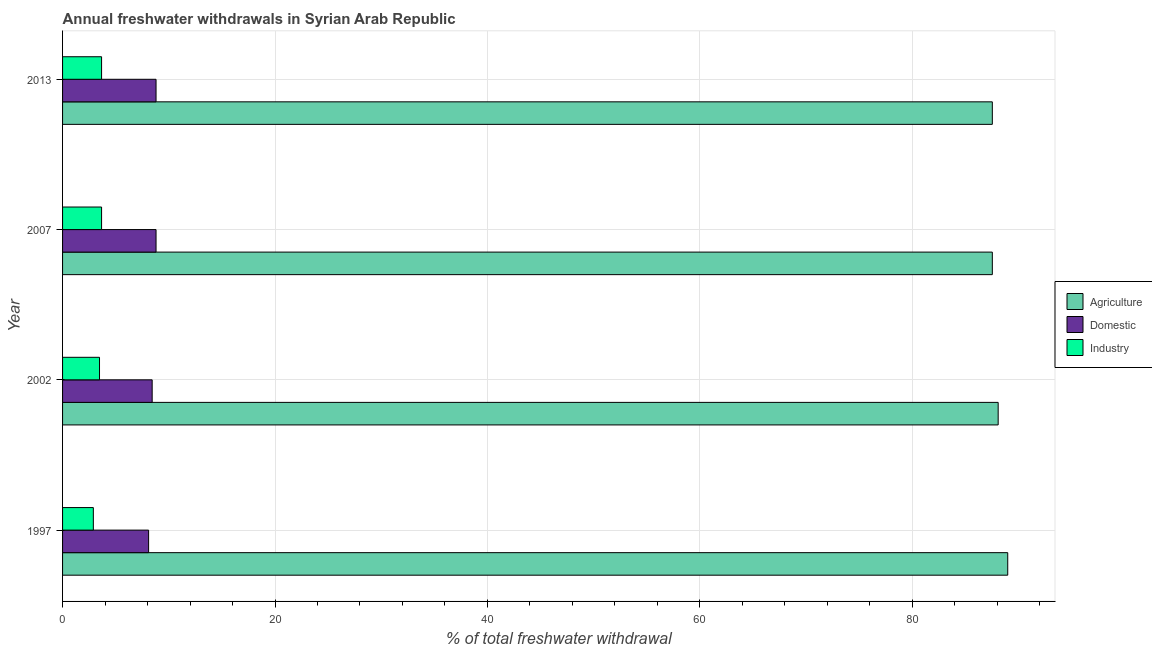Are the number of bars per tick equal to the number of legend labels?
Your response must be concise. Yes. Are the number of bars on each tick of the Y-axis equal?
Your answer should be compact. Yes. How many bars are there on the 1st tick from the top?
Keep it short and to the point. 3. How many bars are there on the 1st tick from the bottom?
Offer a terse response. 3. What is the percentage of freshwater withdrawal for agriculture in 2013?
Keep it short and to the point. 87.53. Across all years, what is the maximum percentage of freshwater withdrawal for agriculture?
Your answer should be compact. 88.98. Across all years, what is the minimum percentage of freshwater withdrawal for domestic purposes?
Provide a succinct answer. 8.1. What is the total percentage of freshwater withdrawal for domestic purposes in the graph?
Provide a succinct answer. 34.14. What is the difference between the percentage of freshwater withdrawal for agriculture in 2002 and that in 2013?
Your answer should be compact. 0.55. What is the difference between the percentage of freshwater withdrawal for domestic purposes in 1997 and the percentage of freshwater withdrawal for industry in 2013?
Make the answer very short. 4.43. What is the average percentage of freshwater withdrawal for domestic purposes per year?
Provide a short and direct response. 8.54. In the year 1997, what is the difference between the percentage of freshwater withdrawal for agriculture and percentage of freshwater withdrawal for industry?
Give a very brief answer. 86.08. What is the ratio of the percentage of freshwater withdrawal for agriculture in 1997 to that in 2013?
Keep it short and to the point. 1.02. What is the difference between the highest and the lowest percentage of freshwater withdrawal for agriculture?
Your response must be concise. 1.45. In how many years, is the percentage of freshwater withdrawal for domestic purposes greater than the average percentage of freshwater withdrawal for domestic purposes taken over all years?
Provide a short and direct response. 2. Is the sum of the percentage of freshwater withdrawal for agriculture in 2002 and 2013 greater than the maximum percentage of freshwater withdrawal for industry across all years?
Provide a short and direct response. Yes. What does the 2nd bar from the top in 2013 represents?
Your response must be concise. Domestic. What does the 3rd bar from the bottom in 2013 represents?
Give a very brief answer. Industry. Is it the case that in every year, the sum of the percentage of freshwater withdrawal for agriculture and percentage of freshwater withdrawal for domestic purposes is greater than the percentage of freshwater withdrawal for industry?
Offer a very short reply. Yes. Are all the bars in the graph horizontal?
Your answer should be very brief. Yes. How many years are there in the graph?
Offer a very short reply. 4. What is the difference between two consecutive major ticks on the X-axis?
Your answer should be very brief. 20. Does the graph contain any zero values?
Keep it short and to the point. No. Does the graph contain grids?
Offer a terse response. Yes. Where does the legend appear in the graph?
Keep it short and to the point. Center right. How many legend labels are there?
Your response must be concise. 3. What is the title of the graph?
Offer a terse response. Annual freshwater withdrawals in Syrian Arab Republic. What is the label or title of the X-axis?
Provide a succinct answer. % of total freshwater withdrawal. What is the label or title of the Y-axis?
Provide a short and direct response. Year. What is the % of total freshwater withdrawal in Agriculture in 1997?
Ensure brevity in your answer.  88.98. What is the % of total freshwater withdrawal in Domestic in 1997?
Your answer should be very brief. 8.1. What is the % of total freshwater withdrawal in Industry in 1997?
Give a very brief answer. 2.9. What is the % of total freshwater withdrawal in Agriculture in 2002?
Give a very brief answer. 88.08. What is the % of total freshwater withdrawal of Domestic in 2002?
Offer a terse response. 8.44. What is the % of total freshwater withdrawal of Industry in 2002?
Provide a short and direct response. 3.48. What is the % of total freshwater withdrawal of Agriculture in 2007?
Offer a very short reply. 87.53. What is the % of total freshwater withdrawal of Domestic in 2007?
Your response must be concise. 8.8. What is the % of total freshwater withdrawal of Industry in 2007?
Make the answer very short. 3.67. What is the % of total freshwater withdrawal of Agriculture in 2013?
Provide a short and direct response. 87.53. What is the % of total freshwater withdrawal of Domestic in 2013?
Your answer should be very brief. 8.8. What is the % of total freshwater withdrawal in Industry in 2013?
Your answer should be compact. 3.67. Across all years, what is the maximum % of total freshwater withdrawal of Agriculture?
Your response must be concise. 88.98. Across all years, what is the maximum % of total freshwater withdrawal in Domestic?
Offer a very short reply. 8.8. Across all years, what is the maximum % of total freshwater withdrawal of Industry?
Ensure brevity in your answer.  3.67. Across all years, what is the minimum % of total freshwater withdrawal in Agriculture?
Offer a very short reply. 87.53. Across all years, what is the minimum % of total freshwater withdrawal in Domestic?
Your answer should be compact. 8.1. Across all years, what is the minimum % of total freshwater withdrawal of Industry?
Make the answer very short. 2.9. What is the total % of total freshwater withdrawal in Agriculture in the graph?
Your response must be concise. 352.12. What is the total % of total freshwater withdrawal of Domestic in the graph?
Your answer should be compact. 34.14. What is the total % of total freshwater withdrawal in Industry in the graph?
Give a very brief answer. 13.72. What is the difference between the % of total freshwater withdrawal in Agriculture in 1997 and that in 2002?
Offer a terse response. 0.9. What is the difference between the % of total freshwater withdrawal in Domestic in 1997 and that in 2002?
Ensure brevity in your answer.  -0.33. What is the difference between the % of total freshwater withdrawal in Industry in 1997 and that in 2002?
Ensure brevity in your answer.  -0.58. What is the difference between the % of total freshwater withdrawal in Agriculture in 1997 and that in 2007?
Your response must be concise. 1.45. What is the difference between the % of total freshwater withdrawal of Industry in 1997 and that in 2007?
Keep it short and to the point. -0.78. What is the difference between the % of total freshwater withdrawal of Agriculture in 1997 and that in 2013?
Offer a very short reply. 1.45. What is the difference between the % of total freshwater withdrawal in Industry in 1997 and that in 2013?
Make the answer very short. -0.78. What is the difference between the % of total freshwater withdrawal of Agriculture in 2002 and that in 2007?
Ensure brevity in your answer.  0.55. What is the difference between the % of total freshwater withdrawal in Domestic in 2002 and that in 2007?
Provide a succinct answer. -0.37. What is the difference between the % of total freshwater withdrawal of Industry in 2002 and that in 2007?
Offer a very short reply. -0.19. What is the difference between the % of total freshwater withdrawal of Agriculture in 2002 and that in 2013?
Offer a terse response. 0.55. What is the difference between the % of total freshwater withdrawal of Domestic in 2002 and that in 2013?
Your response must be concise. -0.37. What is the difference between the % of total freshwater withdrawal of Industry in 2002 and that in 2013?
Your answer should be compact. -0.19. What is the difference between the % of total freshwater withdrawal in Agriculture in 1997 and the % of total freshwater withdrawal in Domestic in 2002?
Provide a short and direct response. 80.55. What is the difference between the % of total freshwater withdrawal of Agriculture in 1997 and the % of total freshwater withdrawal of Industry in 2002?
Keep it short and to the point. 85.5. What is the difference between the % of total freshwater withdrawal in Domestic in 1997 and the % of total freshwater withdrawal in Industry in 2002?
Ensure brevity in your answer.  4.62. What is the difference between the % of total freshwater withdrawal in Agriculture in 1997 and the % of total freshwater withdrawal in Domestic in 2007?
Provide a succinct answer. 80.18. What is the difference between the % of total freshwater withdrawal in Agriculture in 1997 and the % of total freshwater withdrawal in Industry in 2007?
Make the answer very short. 85.31. What is the difference between the % of total freshwater withdrawal in Domestic in 1997 and the % of total freshwater withdrawal in Industry in 2007?
Keep it short and to the point. 4.43. What is the difference between the % of total freshwater withdrawal of Agriculture in 1997 and the % of total freshwater withdrawal of Domestic in 2013?
Provide a short and direct response. 80.18. What is the difference between the % of total freshwater withdrawal in Agriculture in 1997 and the % of total freshwater withdrawal in Industry in 2013?
Make the answer very short. 85.31. What is the difference between the % of total freshwater withdrawal in Domestic in 1997 and the % of total freshwater withdrawal in Industry in 2013?
Your answer should be very brief. 4.43. What is the difference between the % of total freshwater withdrawal of Agriculture in 2002 and the % of total freshwater withdrawal of Domestic in 2007?
Provide a succinct answer. 79.28. What is the difference between the % of total freshwater withdrawal in Agriculture in 2002 and the % of total freshwater withdrawal in Industry in 2007?
Ensure brevity in your answer.  84.41. What is the difference between the % of total freshwater withdrawal of Domestic in 2002 and the % of total freshwater withdrawal of Industry in 2007?
Offer a very short reply. 4.76. What is the difference between the % of total freshwater withdrawal in Agriculture in 2002 and the % of total freshwater withdrawal in Domestic in 2013?
Give a very brief answer. 79.28. What is the difference between the % of total freshwater withdrawal of Agriculture in 2002 and the % of total freshwater withdrawal of Industry in 2013?
Offer a very short reply. 84.41. What is the difference between the % of total freshwater withdrawal of Domestic in 2002 and the % of total freshwater withdrawal of Industry in 2013?
Give a very brief answer. 4.76. What is the difference between the % of total freshwater withdrawal of Agriculture in 2007 and the % of total freshwater withdrawal of Domestic in 2013?
Ensure brevity in your answer.  78.73. What is the difference between the % of total freshwater withdrawal of Agriculture in 2007 and the % of total freshwater withdrawal of Industry in 2013?
Ensure brevity in your answer.  83.86. What is the difference between the % of total freshwater withdrawal of Domestic in 2007 and the % of total freshwater withdrawal of Industry in 2013?
Provide a short and direct response. 5.13. What is the average % of total freshwater withdrawal of Agriculture per year?
Offer a very short reply. 88.03. What is the average % of total freshwater withdrawal of Domestic per year?
Your response must be concise. 8.53. What is the average % of total freshwater withdrawal in Industry per year?
Offer a very short reply. 3.43. In the year 1997, what is the difference between the % of total freshwater withdrawal in Agriculture and % of total freshwater withdrawal in Domestic?
Provide a short and direct response. 80.88. In the year 1997, what is the difference between the % of total freshwater withdrawal in Agriculture and % of total freshwater withdrawal in Industry?
Provide a succinct answer. 86.08. In the year 1997, what is the difference between the % of total freshwater withdrawal of Domestic and % of total freshwater withdrawal of Industry?
Offer a very short reply. 5.2. In the year 2002, what is the difference between the % of total freshwater withdrawal of Agriculture and % of total freshwater withdrawal of Domestic?
Ensure brevity in your answer.  79.64. In the year 2002, what is the difference between the % of total freshwater withdrawal of Agriculture and % of total freshwater withdrawal of Industry?
Your answer should be compact. 84.6. In the year 2002, what is the difference between the % of total freshwater withdrawal in Domestic and % of total freshwater withdrawal in Industry?
Your answer should be compact. 4.96. In the year 2007, what is the difference between the % of total freshwater withdrawal of Agriculture and % of total freshwater withdrawal of Domestic?
Provide a succinct answer. 78.73. In the year 2007, what is the difference between the % of total freshwater withdrawal in Agriculture and % of total freshwater withdrawal in Industry?
Offer a terse response. 83.86. In the year 2007, what is the difference between the % of total freshwater withdrawal in Domestic and % of total freshwater withdrawal in Industry?
Your answer should be compact. 5.13. In the year 2013, what is the difference between the % of total freshwater withdrawal in Agriculture and % of total freshwater withdrawal in Domestic?
Ensure brevity in your answer.  78.73. In the year 2013, what is the difference between the % of total freshwater withdrawal in Agriculture and % of total freshwater withdrawal in Industry?
Offer a very short reply. 83.86. In the year 2013, what is the difference between the % of total freshwater withdrawal of Domestic and % of total freshwater withdrawal of Industry?
Make the answer very short. 5.13. What is the ratio of the % of total freshwater withdrawal in Agriculture in 1997 to that in 2002?
Keep it short and to the point. 1.01. What is the ratio of the % of total freshwater withdrawal in Domestic in 1997 to that in 2002?
Provide a succinct answer. 0.96. What is the ratio of the % of total freshwater withdrawal in Industry in 1997 to that in 2002?
Provide a succinct answer. 0.83. What is the ratio of the % of total freshwater withdrawal in Agriculture in 1997 to that in 2007?
Your answer should be compact. 1.02. What is the ratio of the % of total freshwater withdrawal in Domestic in 1997 to that in 2007?
Ensure brevity in your answer.  0.92. What is the ratio of the % of total freshwater withdrawal of Industry in 1997 to that in 2007?
Keep it short and to the point. 0.79. What is the ratio of the % of total freshwater withdrawal of Agriculture in 1997 to that in 2013?
Offer a very short reply. 1.02. What is the ratio of the % of total freshwater withdrawal in Domestic in 1997 to that in 2013?
Keep it short and to the point. 0.92. What is the ratio of the % of total freshwater withdrawal in Industry in 1997 to that in 2013?
Keep it short and to the point. 0.79. What is the ratio of the % of total freshwater withdrawal in Domestic in 2002 to that in 2007?
Provide a short and direct response. 0.96. What is the ratio of the % of total freshwater withdrawal in Industry in 2002 to that in 2007?
Your response must be concise. 0.95. What is the ratio of the % of total freshwater withdrawal of Domestic in 2002 to that in 2013?
Give a very brief answer. 0.96. What is the ratio of the % of total freshwater withdrawal in Industry in 2002 to that in 2013?
Keep it short and to the point. 0.95. What is the ratio of the % of total freshwater withdrawal of Agriculture in 2007 to that in 2013?
Offer a terse response. 1. What is the ratio of the % of total freshwater withdrawal in Industry in 2007 to that in 2013?
Your response must be concise. 1. What is the difference between the highest and the second highest % of total freshwater withdrawal of Industry?
Give a very brief answer. 0. What is the difference between the highest and the lowest % of total freshwater withdrawal in Agriculture?
Ensure brevity in your answer.  1.45. What is the difference between the highest and the lowest % of total freshwater withdrawal in Industry?
Your response must be concise. 0.78. 